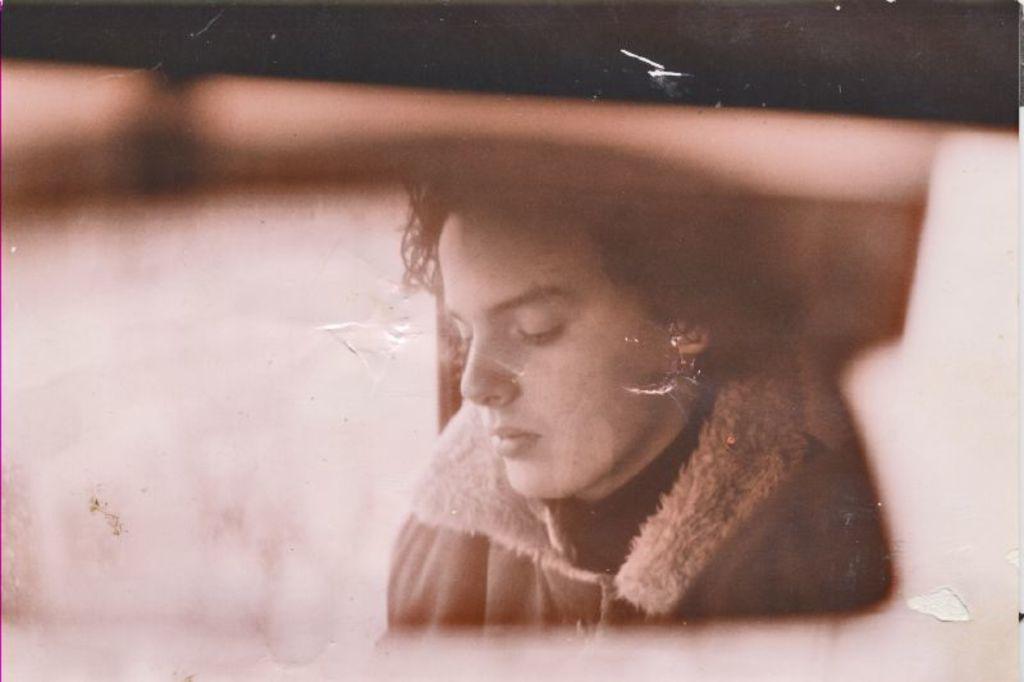Please provide a concise description of this image. In this image I can see a person wearing jacket. Background is in black and brown color. The image is in black and white. 